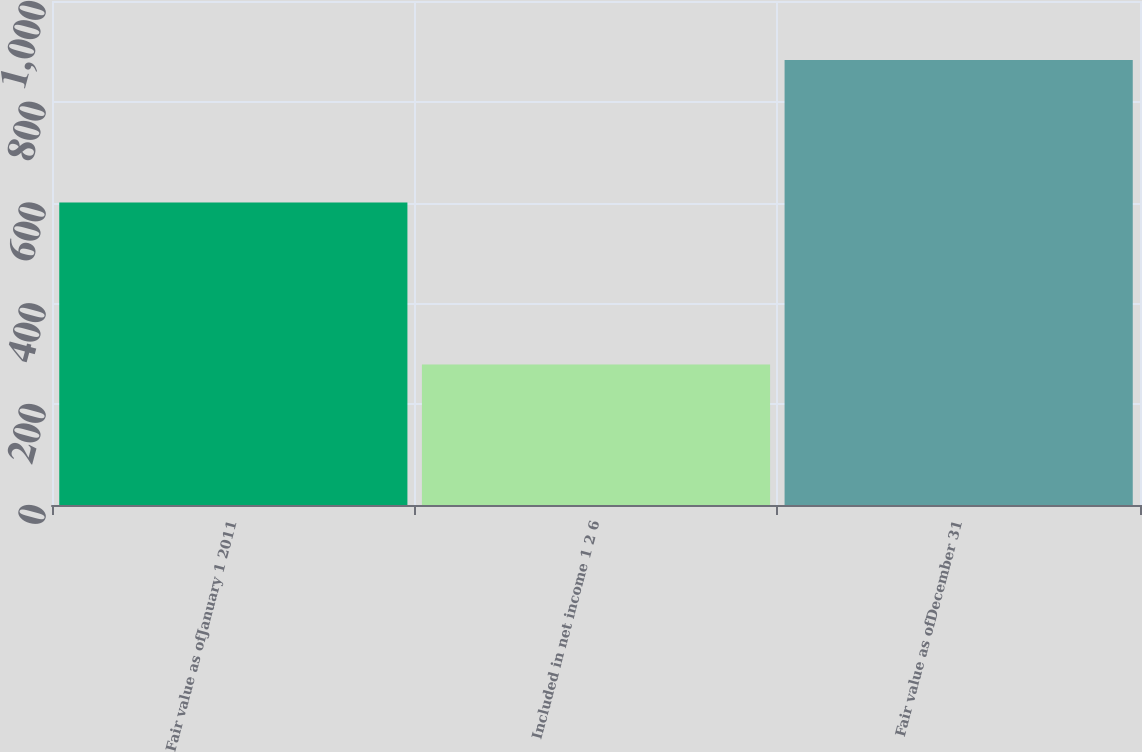Convert chart to OTSL. <chart><loc_0><loc_0><loc_500><loc_500><bar_chart><fcel>Fair value as ofJanuary 1 2011<fcel>Included in net income 1 2 6<fcel>Fair value as ofDecember 31<nl><fcel>600<fcel>279<fcel>883<nl></chart> 